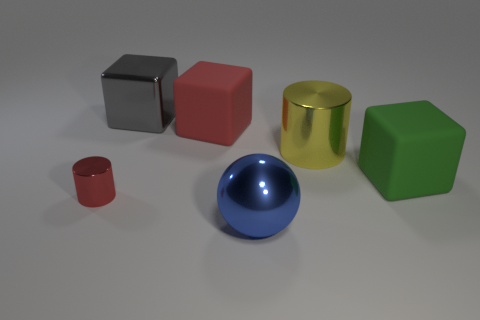Subtract all gray blocks. How many blocks are left? 2 Add 1 red cubes. How many objects exist? 7 Subtract 1 spheres. How many spheres are left? 0 Subtract all gray cubes. How many cubes are left? 2 Subtract all balls. How many objects are left? 5 Subtract all yellow balls. How many gray blocks are left? 1 Subtract all tiny metallic objects. Subtract all small yellow blocks. How many objects are left? 5 Add 6 big red objects. How many big red objects are left? 7 Add 4 large blue things. How many large blue things exist? 5 Subtract 1 green blocks. How many objects are left? 5 